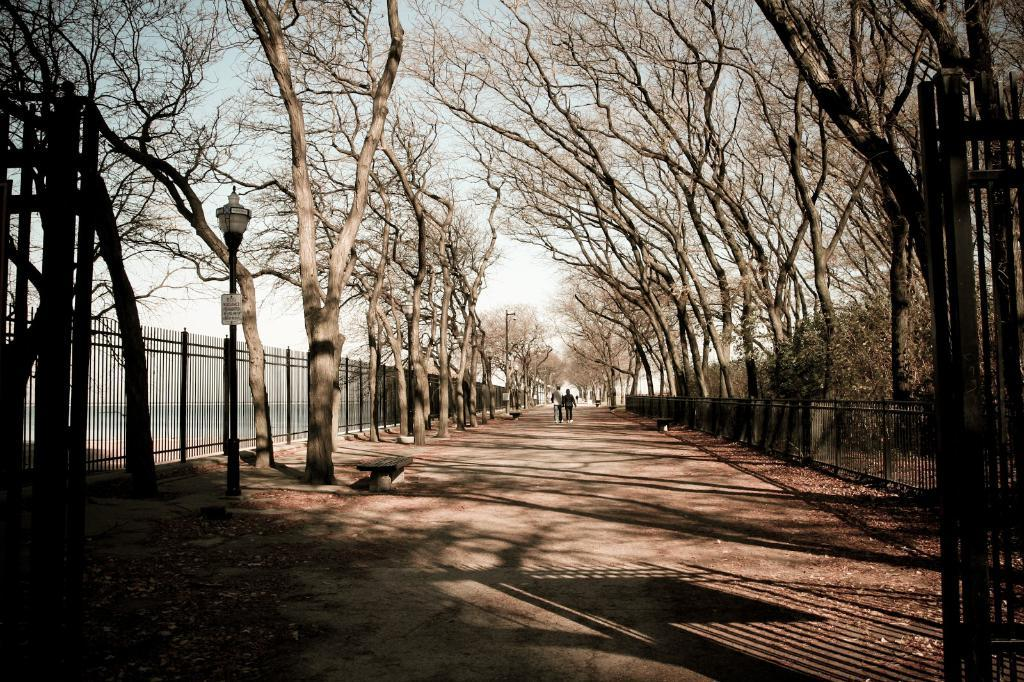What type of natural elements can be seen in the image? There are trees in the image. What part of the natural environment is visible in the image? The sky is visible in the image. What type of man-made structure is present in the image? There is a fence in the image. What type of artificial light source is present in the image? A street lamp is present in the image. How many people are walking in the image? There are two people walking in the image. Is the hour depicted in the image, and if so, what time is it? The image does not depict a specific hour or time; it only shows trees, the sky, a fence, a street lamp, and two people walking. Is there any quicksand present in the image? There is no quicksand present in the image. 